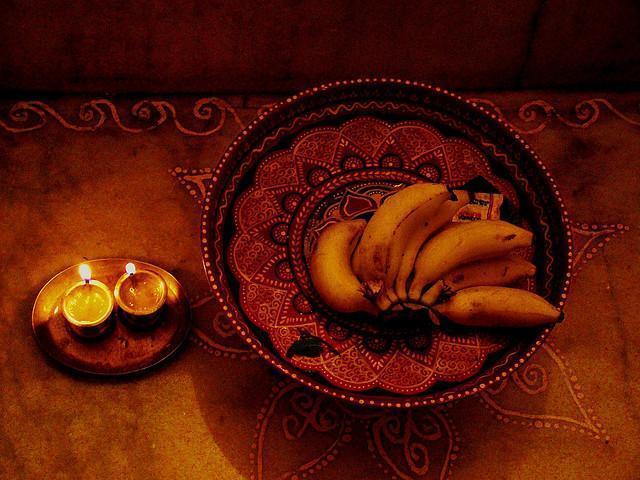How many bananas are in the basket?
Give a very brief answer. 6. How many legs does the cat have?
Give a very brief answer. 0. 